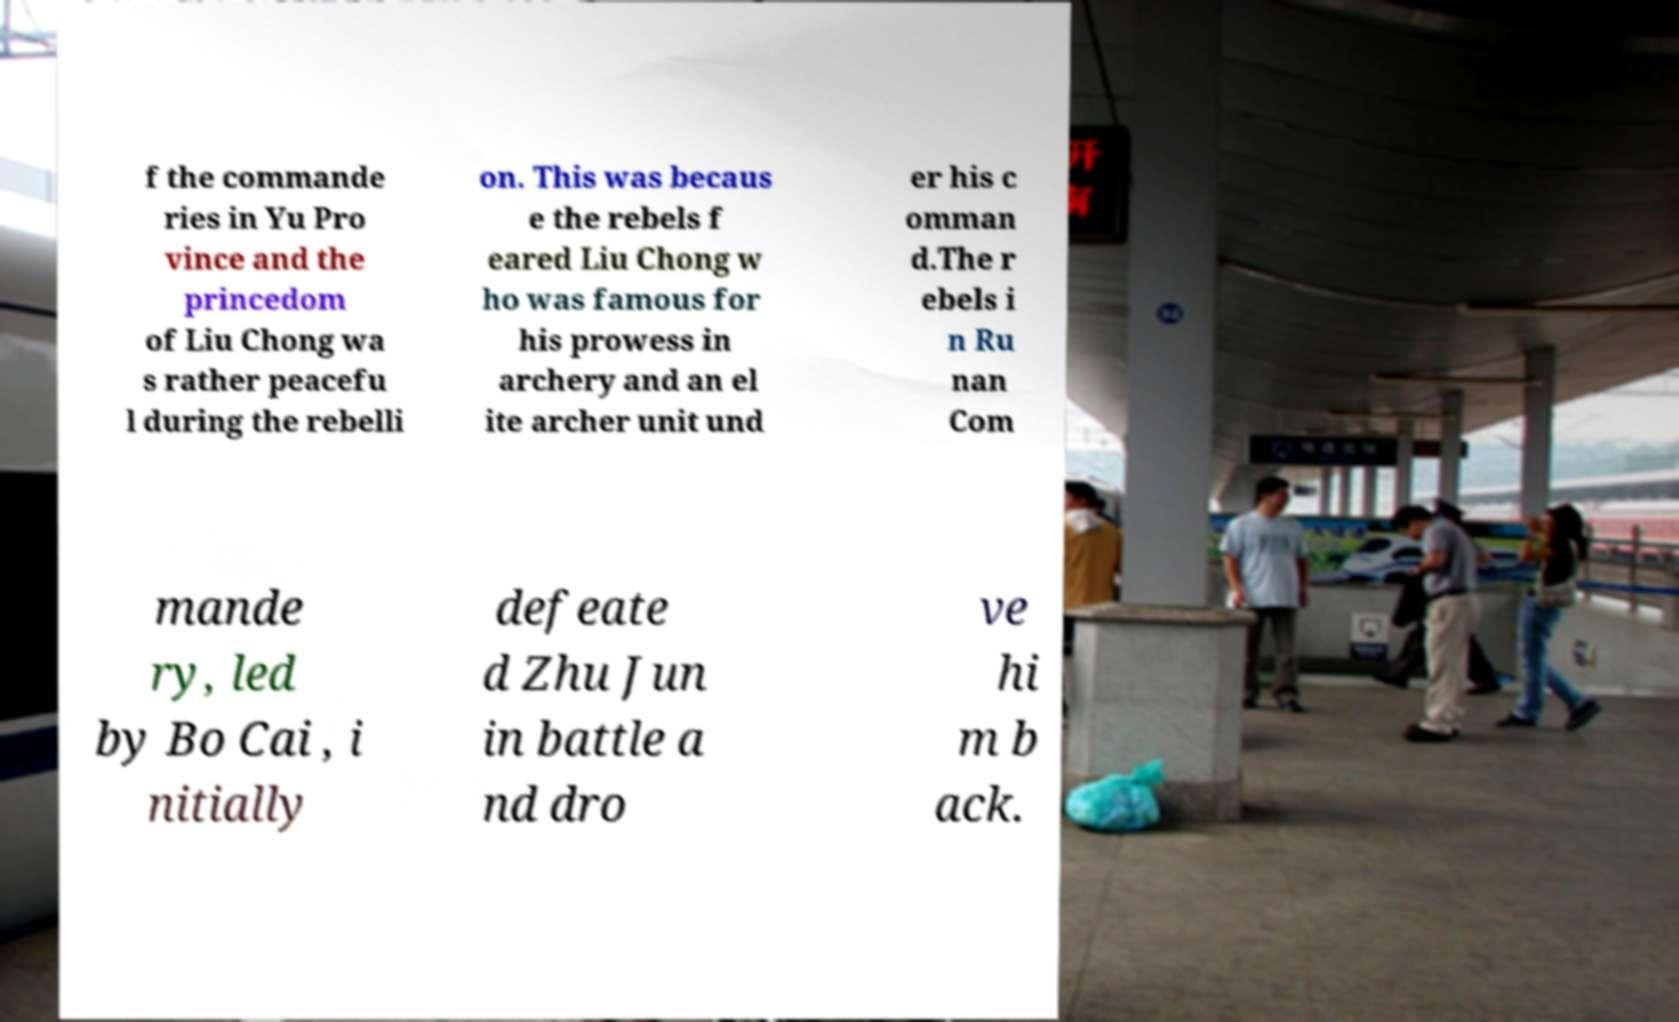I need the written content from this picture converted into text. Can you do that? f the commande ries in Yu Pro vince and the princedom of Liu Chong wa s rather peacefu l during the rebelli on. This was becaus e the rebels f eared Liu Chong w ho was famous for his prowess in archery and an el ite archer unit und er his c omman d.The r ebels i n Ru nan Com mande ry, led by Bo Cai , i nitially defeate d Zhu Jun in battle a nd dro ve hi m b ack. 